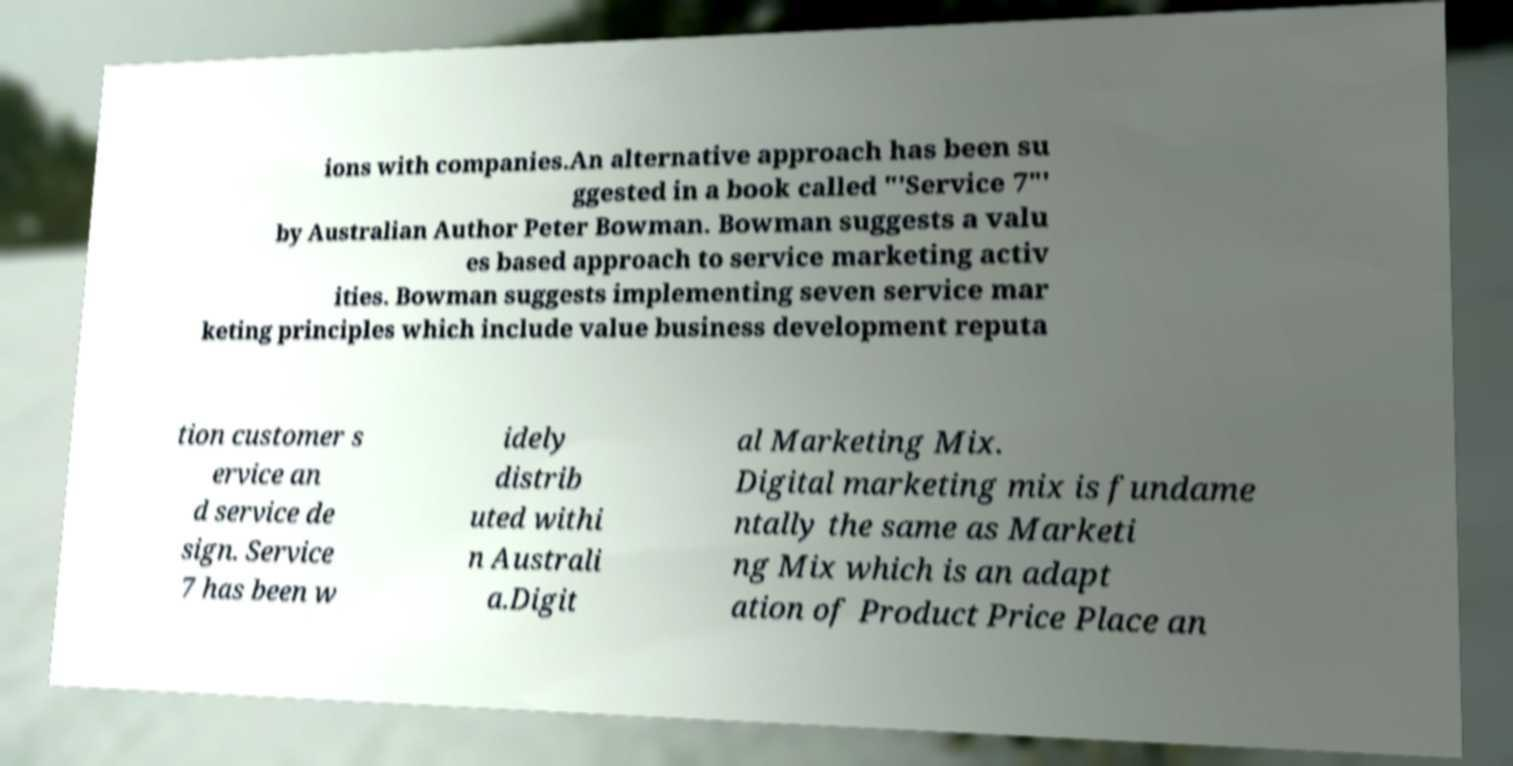Can you accurately transcribe the text from the provided image for me? ions with companies.An alternative approach has been su ggested in a book called "'Service 7"' by Australian Author Peter Bowman. Bowman suggests a valu es based approach to service marketing activ ities. Bowman suggests implementing seven service mar keting principles which include value business development reputa tion customer s ervice an d service de sign. Service 7 has been w idely distrib uted withi n Australi a.Digit al Marketing Mix. Digital marketing mix is fundame ntally the same as Marketi ng Mix which is an adapt ation of Product Price Place an 